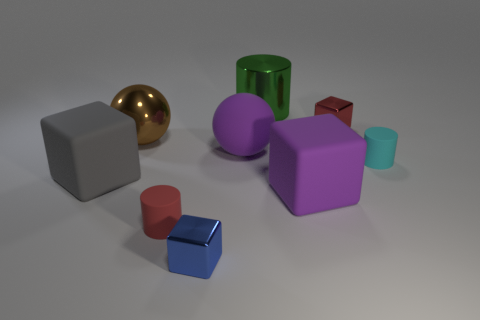There is a gray object that is made of the same material as the small cyan thing; what is its shape?
Provide a succinct answer. Cube. The cyan cylinder is what size?
Offer a very short reply. Small. Do the blue metal object and the red matte cylinder have the same size?
Make the answer very short. Yes. How many things are matte cylinders that are left of the tiny cyan cylinder or large cubes in front of the large gray block?
Your response must be concise. 2. There is a tiny cube to the right of the purple thing behind the large purple rubber cube; how many blue things are right of it?
Make the answer very short. 0. How big is the cylinder left of the blue block?
Offer a very short reply. Small. What number of blue blocks have the same size as the red shiny block?
Your response must be concise. 1. There is a brown ball; is it the same size as the object left of the metallic ball?
Your answer should be compact. Yes. What number of things are either large cyan metal blocks or red things?
Give a very brief answer. 2. What number of things have the same color as the matte ball?
Provide a succinct answer. 1. 